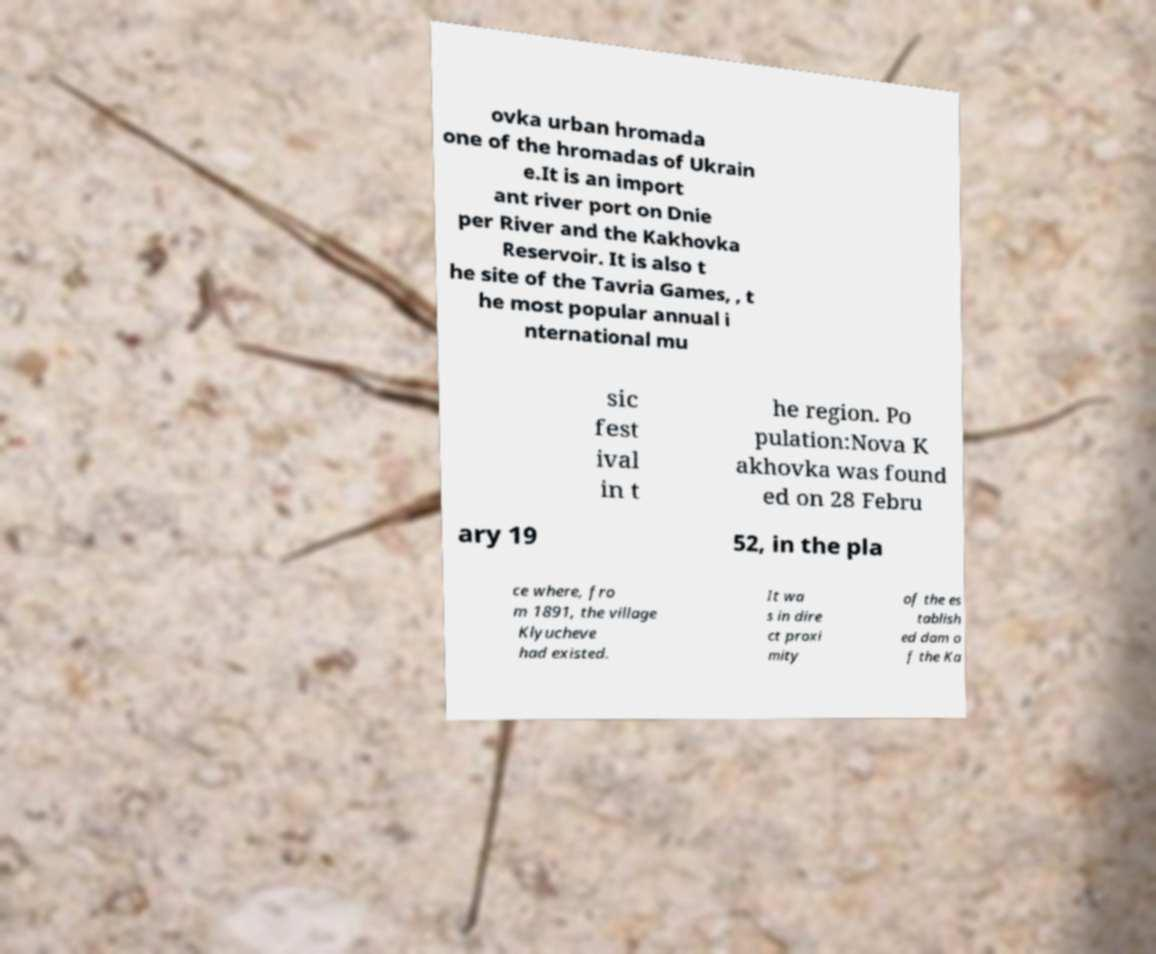I need the written content from this picture converted into text. Can you do that? ovka urban hromada one of the hromadas of Ukrain e.It is an import ant river port on Dnie per River and the Kakhovka Reservoir. It is also t he site of the Tavria Games, , t he most popular annual i nternational mu sic fest ival in t he region. Po pulation:Nova K akhovka was found ed on 28 Febru ary 19 52, in the pla ce where, fro m 1891, the village Klyucheve had existed. It wa s in dire ct proxi mity of the es tablish ed dam o f the Ka 